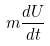<formula> <loc_0><loc_0><loc_500><loc_500>m \frac { d U } { d t }</formula> 